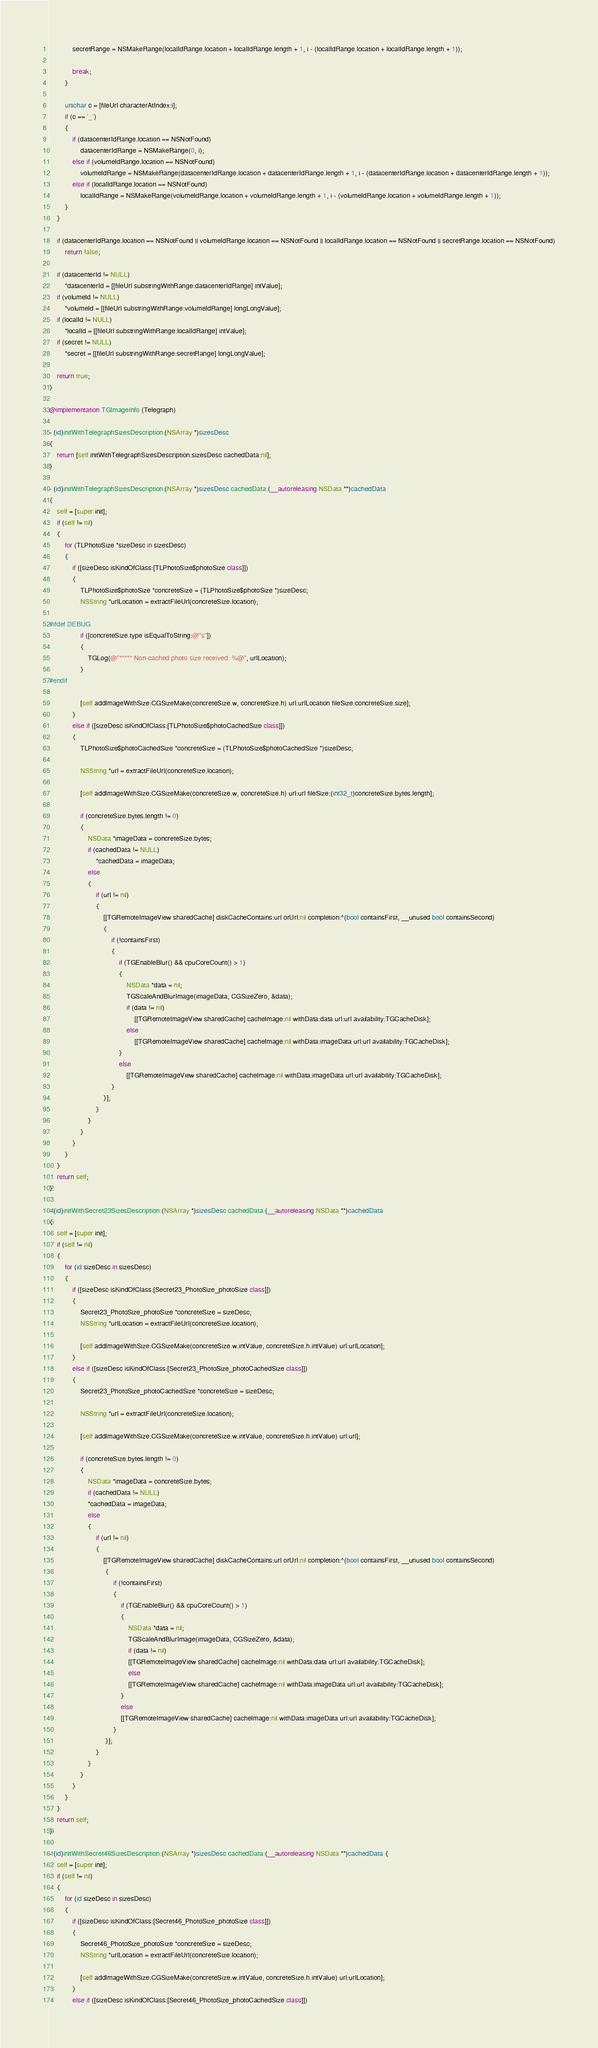Convert code to text. <code><loc_0><loc_0><loc_500><loc_500><_ObjectiveC_>            secretRange = NSMakeRange(localIdRange.location + localIdRange.length + 1, i - (localIdRange.location + localIdRange.length + 1));
            
            break;
        }
        
        unichar c = [fileUrl characterAtIndex:i];
        if (c == '_')
        {
            if (datacenterIdRange.location == NSNotFound)
                datacenterIdRange = NSMakeRange(0, i);
            else if (volumeIdRange.location == NSNotFound)
                volumeIdRange = NSMakeRange(datacenterIdRange.location + datacenterIdRange.length + 1, i - (datacenterIdRange.location + datacenterIdRange.length + 1));
            else if (localIdRange.location == NSNotFound)
                localIdRange = NSMakeRange(volumeIdRange.location + volumeIdRange.length + 1, i - (volumeIdRange.location + volumeIdRange.length + 1));
        }
    }
    
    if (datacenterIdRange.location == NSNotFound || volumeIdRange.location == NSNotFound || localIdRange.location == NSNotFound || secretRange.location == NSNotFound)
        return false;
    
    if (datacenterId != NULL)
        *datacenterId = [[fileUrl substringWithRange:datacenterIdRange] intValue];
    if (volumeId != NULL)
        *volumeId = [[fileUrl substringWithRange:volumeIdRange] longLongValue];
    if (localId != NULL)
        *localId = [[fileUrl substringWithRange:localIdRange] intValue];
    if (secret != NULL)
        *secret = [[fileUrl substringWithRange:secretRange] longLongValue];
    
    return true;
}

@implementation TGImageInfo (Telegraph)

- (id)initWithTelegraphSizesDescription:(NSArray *)sizesDesc
{
    return [self initWithTelegraphSizesDescription:sizesDesc cachedData:nil];
}

- (id)initWithTelegraphSizesDescription:(NSArray *)sizesDesc cachedData:(__autoreleasing NSData **)cachedData
{
    self = [super init];
    if (self != nil)
    {   
        for (TLPhotoSize *sizeDesc in sizesDesc)
        {
            if ([sizeDesc isKindOfClass:[TLPhotoSize$photoSize class]])
            {
                TLPhotoSize$photoSize *concreteSize = (TLPhotoSize$photoSize *)sizeDesc;
                NSString *urlLocation = extractFileUrl(concreteSize.location);
                
#ifdef DEBUG
                if ([concreteSize.type isEqualToString:@"s"])
                {
                    TGLog(@"***** Non-cached photo size received: %@", urlLocation);
                }
#endif
                
                [self addImageWithSize:CGSizeMake(concreteSize.w, concreteSize.h) url:urlLocation fileSize:concreteSize.size];
            }
            else if ([sizeDesc isKindOfClass:[TLPhotoSize$photoCachedSize class]])
            {
                TLPhotoSize$photoCachedSize *concreteSize = (TLPhotoSize$photoCachedSize *)sizeDesc;
                
                NSString *url = extractFileUrl(concreteSize.location);
                
                [self addImageWithSize:CGSizeMake(concreteSize.w, concreteSize.h) url:url fileSize:(int32_t)concreteSize.bytes.length];
                
                if (concreteSize.bytes.length != 0)
                {
                    NSData *imageData = concreteSize.bytes;
                    if (cachedData != NULL)
                        *cachedData = imageData;
                    else
                    {
                        if (url != nil)
                        {
                            [[TGRemoteImageView sharedCache] diskCacheContains:url orUrl:nil completion:^(bool containsFirst, __unused bool containsSecond)
                            {
                                if (!containsFirst)
                                {
                                    if (TGEnableBlur() && cpuCoreCount() > 1)
                                    {
                                        NSData *data = nil;
                                        TGScaleAndBlurImage(imageData, CGSizeZero, &data);
                                        if (data != nil)
                                            [[TGRemoteImageView sharedCache] cacheImage:nil withData:data url:url availability:TGCacheDisk];
                                        else
                                            [[TGRemoteImageView sharedCache] cacheImage:nil withData:imageData url:url availability:TGCacheDisk];
                                    }
                                    else
                                        [[TGRemoteImageView sharedCache] cacheImage:nil withData:imageData url:url availability:TGCacheDisk];
                                }
                            }];
                        }
                    }
                }
            }
        }
    }
    return self;
}

- (id)initWithSecret23SizesDescription:(NSArray *)sizesDesc cachedData:(__autoreleasing NSData **)cachedData
{
    self = [super init];
    if (self != nil)
    {
        for (id sizeDesc in sizesDesc)
        {
            if ([sizeDesc isKindOfClass:[Secret23_PhotoSize_photoSize class]])
            {
                Secret23_PhotoSize_photoSize *concreteSize = sizeDesc;
                NSString *urlLocation = extractFileUrl(concreteSize.location);
                
                [self addImageWithSize:CGSizeMake(concreteSize.w.intValue, concreteSize.h.intValue) url:urlLocation];
            }
            else if ([sizeDesc isKindOfClass:[Secret23_PhotoSize_photoCachedSize class]])
            {
                Secret23_PhotoSize_photoCachedSize *concreteSize = sizeDesc;
                
                NSString *url = extractFileUrl(concreteSize.location);
                
                [self addImageWithSize:CGSizeMake(concreteSize.w.intValue, concreteSize.h.intValue) url:url];
                
                if (concreteSize.bytes.length != 0)
                {
                    NSData *imageData = concreteSize.bytes;
                    if (cachedData != NULL)
                    *cachedData = imageData;
                    else
                    {
                        if (url != nil)
                        {
                            [[TGRemoteImageView sharedCache] diskCacheContains:url orUrl:nil completion:^(bool containsFirst, __unused bool containsSecond)
                             {
                                 if (!containsFirst)
                                 {
                                     if (TGEnableBlur() && cpuCoreCount() > 1)
                                     {
                                         NSData *data = nil;
                                         TGScaleAndBlurImage(imageData, CGSizeZero, &data);
                                         if (data != nil)
                                         [[TGRemoteImageView sharedCache] cacheImage:nil withData:data url:url availability:TGCacheDisk];
                                         else
                                         [[TGRemoteImageView sharedCache] cacheImage:nil withData:imageData url:url availability:TGCacheDisk];
                                     }
                                     else
                                     [[TGRemoteImageView sharedCache] cacheImage:nil withData:imageData url:url availability:TGCacheDisk];
                                 }
                             }];
                        }
                    }
                }
            }
        }
    }
    return self;
}

- (id)initWithSecret46SizesDescription:(NSArray *)sizesDesc cachedData:(__autoreleasing NSData **)cachedData {
    self = [super init];
    if (self != nil)
    {
        for (id sizeDesc in sizesDesc)
        {
            if ([sizeDesc isKindOfClass:[Secret46_PhotoSize_photoSize class]])
            {
                Secret46_PhotoSize_photoSize *concreteSize = sizeDesc;
                NSString *urlLocation = extractFileUrl(concreteSize.location);
                
                [self addImageWithSize:CGSizeMake(concreteSize.w.intValue, concreteSize.h.intValue) url:urlLocation];
            }
            else if ([sizeDesc isKindOfClass:[Secret46_PhotoSize_photoCachedSize class]])</code> 